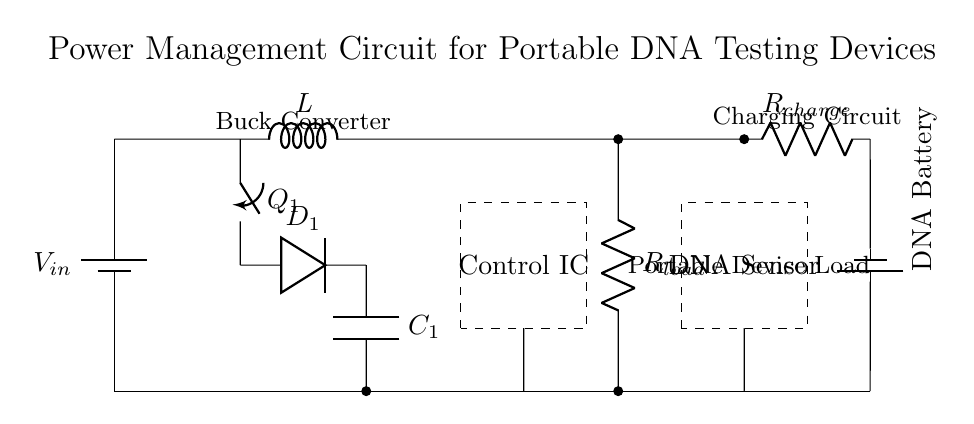What is the primary function of the buck converter in this circuit? The primary function of the buck converter is to step down the voltage from the input source to a lower level suitable for the DNA testing device. Buck converters are specifically designed to efficiently convert high input voltages to lower output voltages, which is essential for portable applications where battery efficiency is crucial.
Answer: Step down voltage What component is responsible for storing energy in this circuit? The component responsible for storing energy in this circuit is the capacitor (C1). Capacitors accumulate charge and release energy when needed, which helps smooth out voltage fluctuations and provides a more stable supply to the load.
Answer: C1 What does the control IC do in this circuit? The control IC regulates the operation of the power management circuit by adjusting the switching of the buck converter and ensuring proper voltage levels are maintained to the connected devices. It serves as the brain of the circuit, managing energy flow efficiently.
Answer: Regulates power In which part of the diagram is the DNA sensor located? The DNA sensor is located in the area marked with a dashed rectangle, indicating its physical space within the circuit layout. This sensor interacts with the biological sample and requires power from the circuit to operate effectively.
Answer: Dashed rectangle What is the purpose of the charging circuit in this design? The purpose of the charging circuit is to safely charge the DNA battery while ensuring that the energy needed for the operation of the device is available. It includes the resistor (R_charge) which may limit the current to avoid overcharging and damage to the battery.
Answer: Charge the battery How does the switch Q1 influence the operation of the buck converter? The switch Q1 controls the flow of current through the inductor and output capacitor in the buck converter. By opening and closing, it regulates the energy transfer to the load, affecting the output voltage and current delivered to the system.
Answer: Controls current flow What type of load is connected in this circuit? The load connected in this circuit is a portable device load, specifically designed for applications requiring low power consumption and efficient energy usage, typical for devices like DNA testing instruments.
Answer: Portable device load 